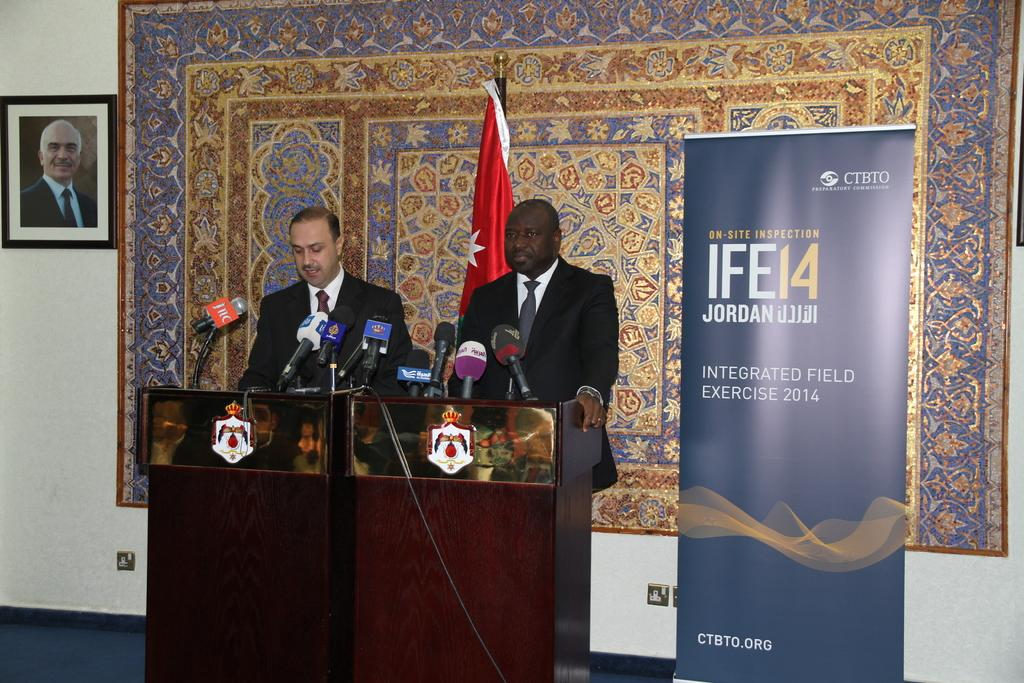<image>
Render a clear and concise summary of the photo. Two men are standing at a podium next to a sign that says IFE14. 